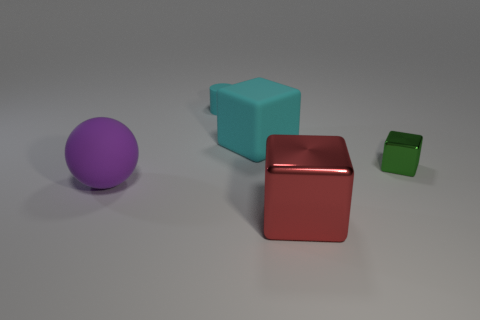Add 2 matte cubes. How many objects exist? 7 Subtract all blocks. How many objects are left? 2 Add 3 big cyan cubes. How many big cyan cubes are left? 4 Add 1 blue metal balls. How many blue metal balls exist? 1 Subtract 0 green balls. How many objects are left? 5 Subtract all purple spheres. Subtract all cyan cylinders. How many objects are left? 3 